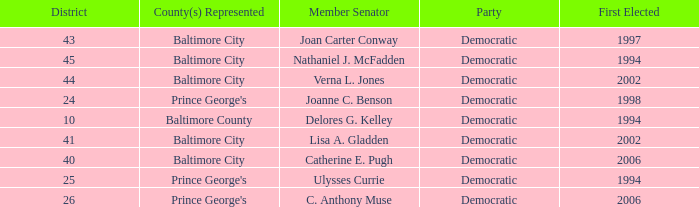Who was firest elected in 2002 in a district larger than 41? Verna L. Jones. 